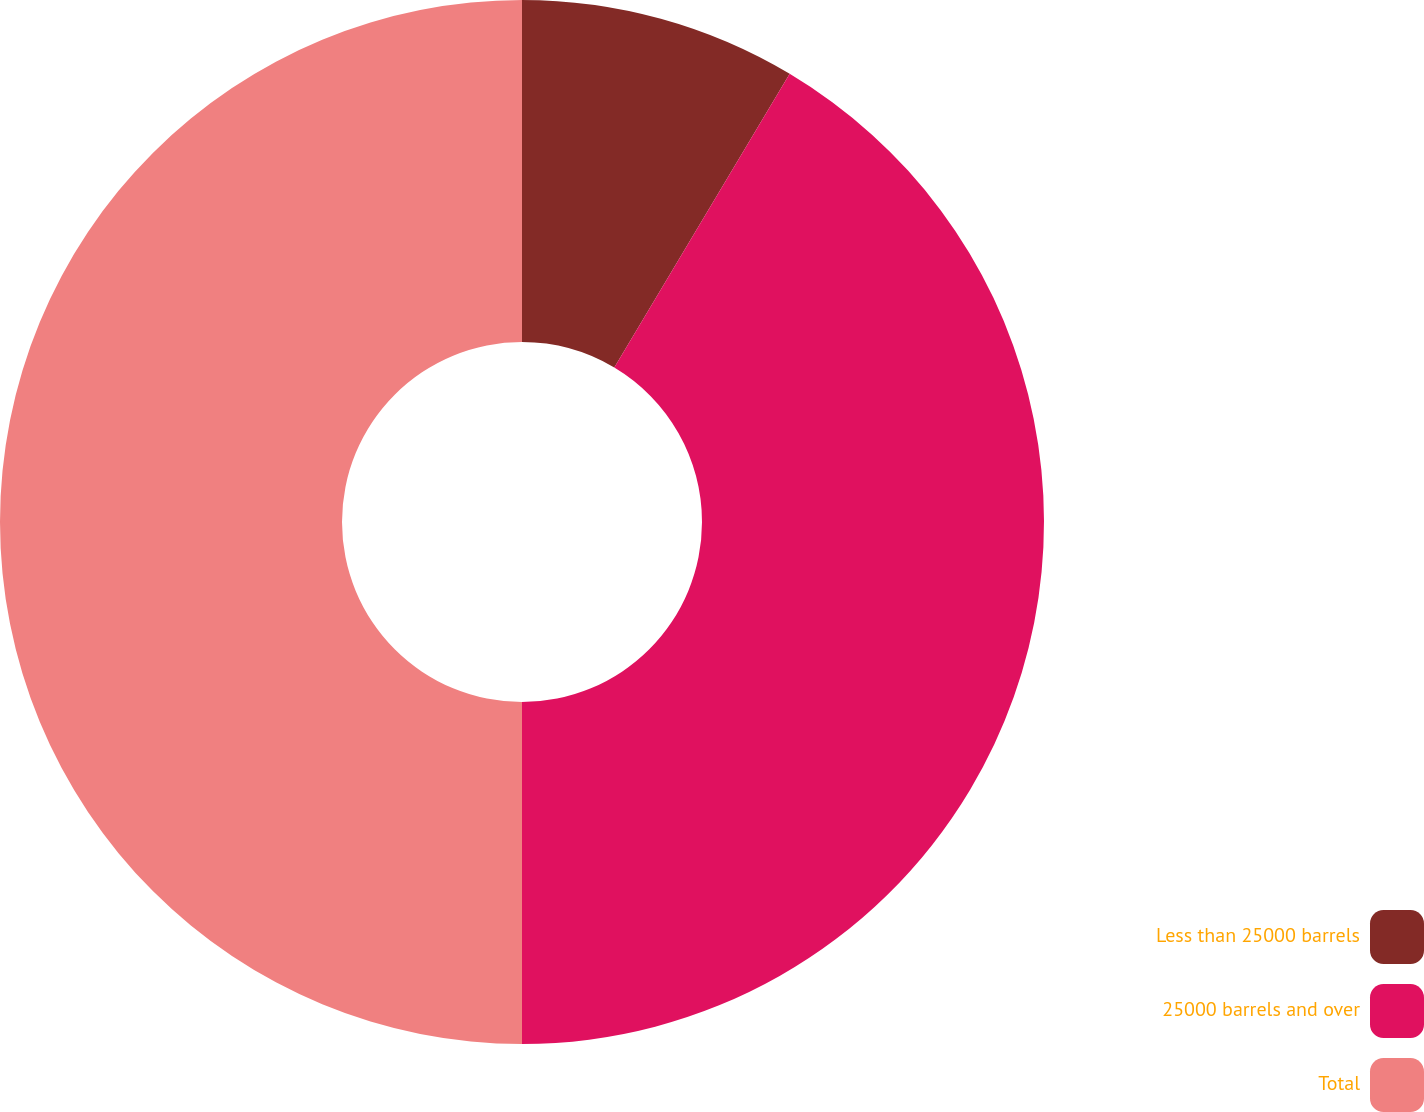<chart> <loc_0><loc_0><loc_500><loc_500><pie_chart><fcel>Less than 25000 barrels<fcel>25000 barrels and over<fcel>Total<nl><fcel>8.57%<fcel>41.43%<fcel>50.0%<nl></chart> 